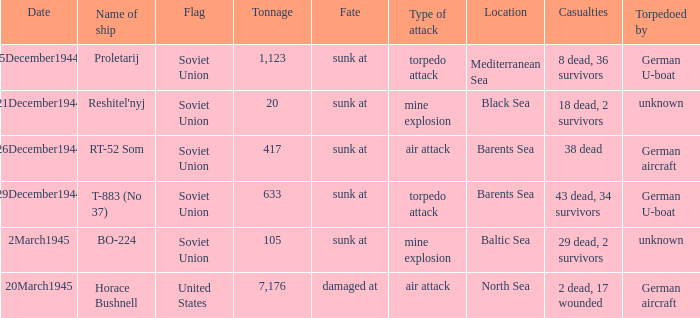What is the average tonnage of the ship named proletarij? 1123.0. 